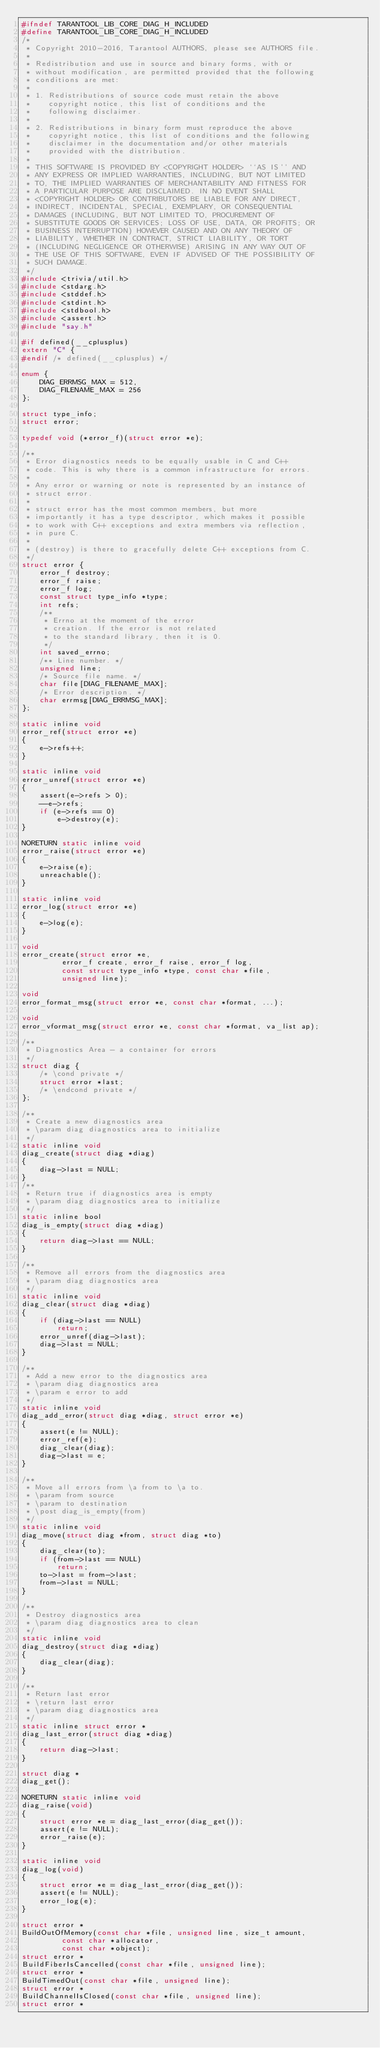<code> <loc_0><loc_0><loc_500><loc_500><_C_>#ifndef TARANTOOL_LIB_CORE_DIAG_H_INCLUDED
#define TARANTOOL_LIB_CORE_DIAG_H_INCLUDED
/*
 * Copyright 2010-2016, Tarantool AUTHORS, please see AUTHORS file.
 *
 * Redistribution and use in source and binary forms, with or
 * without modification, are permitted provided that the following
 * conditions are met:
 *
 * 1. Redistributions of source code must retain the above
 *    copyright notice, this list of conditions and the
 *    following disclaimer.
 *
 * 2. Redistributions in binary form must reproduce the above
 *    copyright notice, this list of conditions and the following
 *    disclaimer in the documentation and/or other materials
 *    provided with the distribution.
 *
 * THIS SOFTWARE IS PROVIDED BY <COPYRIGHT HOLDER> ``AS IS'' AND
 * ANY EXPRESS OR IMPLIED WARRANTIES, INCLUDING, BUT NOT LIMITED
 * TO, THE IMPLIED WARRANTIES OF MERCHANTABILITY AND FITNESS FOR
 * A PARTICULAR PURPOSE ARE DISCLAIMED. IN NO EVENT SHALL
 * <COPYRIGHT HOLDER> OR CONTRIBUTORS BE LIABLE FOR ANY DIRECT,
 * INDIRECT, INCIDENTAL, SPECIAL, EXEMPLARY, OR CONSEQUENTIAL
 * DAMAGES (INCLUDING, BUT NOT LIMITED TO, PROCUREMENT OF
 * SUBSTITUTE GOODS OR SERVICES; LOSS OF USE, DATA, OR PROFITS; OR
 * BUSINESS INTERRUPTION) HOWEVER CAUSED AND ON ANY THEORY OF
 * LIABILITY, WHETHER IN CONTRACT, STRICT LIABILITY, OR TORT
 * (INCLUDING NEGLIGENCE OR OTHERWISE) ARISING IN ANY WAY OUT OF
 * THE USE OF THIS SOFTWARE, EVEN IF ADVISED OF THE POSSIBILITY OF
 * SUCH DAMAGE.
 */
#include <trivia/util.h>
#include <stdarg.h>
#include <stddef.h>
#include <stdint.h>
#include <stdbool.h>
#include <assert.h>
#include "say.h"

#if defined(__cplusplus)
extern "C" {
#endif /* defined(__cplusplus) */

enum {
	DIAG_ERRMSG_MAX = 512,
	DIAG_FILENAME_MAX = 256
};

struct type_info;
struct error;

typedef void (*error_f)(struct error *e);

/**
 * Error diagnostics needs to be equally usable in C and C++
 * code. This is why there is a common infrastructure for errors.
 *
 * Any error or warning or note is represented by an instance of
 * struct error.
 *
 * struct error has the most common members, but more
 * importantly it has a type descriptor, which makes it possible
 * to work with C++ exceptions and extra members via reflection,
 * in pure C.
 *
 * (destroy) is there to gracefully delete C++ exceptions from C.
 */
struct error {
	error_f destroy;
	error_f raise;
	error_f log;
	const struct type_info *type;
	int refs;
	/**
	 * Errno at the moment of the error
	 * creation. If the error is not related
	 * to the standard library, then it is 0.
	 */
	int saved_errno;
	/** Line number. */
	unsigned line;
	/* Source file name. */
	char file[DIAG_FILENAME_MAX];
	/* Error description. */
	char errmsg[DIAG_ERRMSG_MAX];
};

static inline void
error_ref(struct error *e)
{
	e->refs++;
}

static inline void
error_unref(struct error *e)
{
	assert(e->refs > 0);
	--e->refs;
	if (e->refs == 0)
		e->destroy(e);
}

NORETURN static inline void
error_raise(struct error *e)
{
	e->raise(e);
	unreachable();
}

static inline void
error_log(struct error *e)
{
	e->log(e);
}

void
error_create(struct error *e,
	     error_f create, error_f raise, error_f log,
	     const struct type_info *type, const char *file,
	     unsigned line);

void
error_format_msg(struct error *e, const char *format, ...);

void
error_vformat_msg(struct error *e, const char *format, va_list ap);

/**
 * Diagnostics Area - a container for errors
 */
struct diag {
	/* \cond private */
	struct error *last;
	/* \endcond private */
};

/**
 * Create a new diagnostics area
 * \param diag diagnostics area to initialize
 */
static inline void
diag_create(struct diag *diag)
{
	diag->last = NULL;
}
/**
 * Return true if diagnostics area is empty
 * \param diag diagnostics area to initialize
 */
static inline bool
diag_is_empty(struct diag *diag)
{
	return diag->last == NULL;
}

/**
 * Remove all errors from the diagnostics area
 * \param diag diagnostics area
 */
static inline void
diag_clear(struct diag *diag)
{
	if (diag->last == NULL)
		return;
	error_unref(diag->last);
	diag->last = NULL;
}

/**
 * Add a new error to the diagnostics area
 * \param diag diagnostics area
 * \param e error to add
 */
static inline void
diag_add_error(struct diag *diag, struct error *e)
{
	assert(e != NULL);
	error_ref(e);
	diag_clear(diag);
	diag->last = e;
}

/**
 * Move all errors from \a from to \a to.
 * \param from source
 * \param to destination
 * \post diag_is_empty(from)
 */
static inline void
diag_move(struct diag *from, struct diag *to)
{
	diag_clear(to);
	if (from->last == NULL)
		return;
	to->last = from->last;
	from->last = NULL;
}

/**
 * Destroy diagnostics area
 * \param diag diagnostics area to clean
 */
static inline void
diag_destroy(struct diag *diag)
{
	diag_clear(diag);
}

/**
 * Return last error
 * \return last error
 * \param diag diagnostics area
 */
static inline struct error *
diag_last_error(struct diag *diag)
{
	return diag->last;
}

struct diag *
diag_get();

NORETURN static inline void
diag_raise(void)
{
	struct error *e = diag_last_error(diag_get());
	assert(e != NULL);
	error_raise(e);
}

static inline void
diag_log(void)
{
	struct error *e = diag_last_error(diag_get());
	assert(e != NULL);
	error_log(e);
}

struct error *
BuildOutOfMemory(const char *file, unsigned line, size_t amount,
		 const char *allocator,
		 const char *object);
struct error *
BuildFiberIsCancelled(const char *file, unsigned line);
struct error *
BuildTimedOut(const char *file, unsigned line);
struct error *
BuildChannelIsClosed(const char *file, unsigned line);
struct error *</code> 